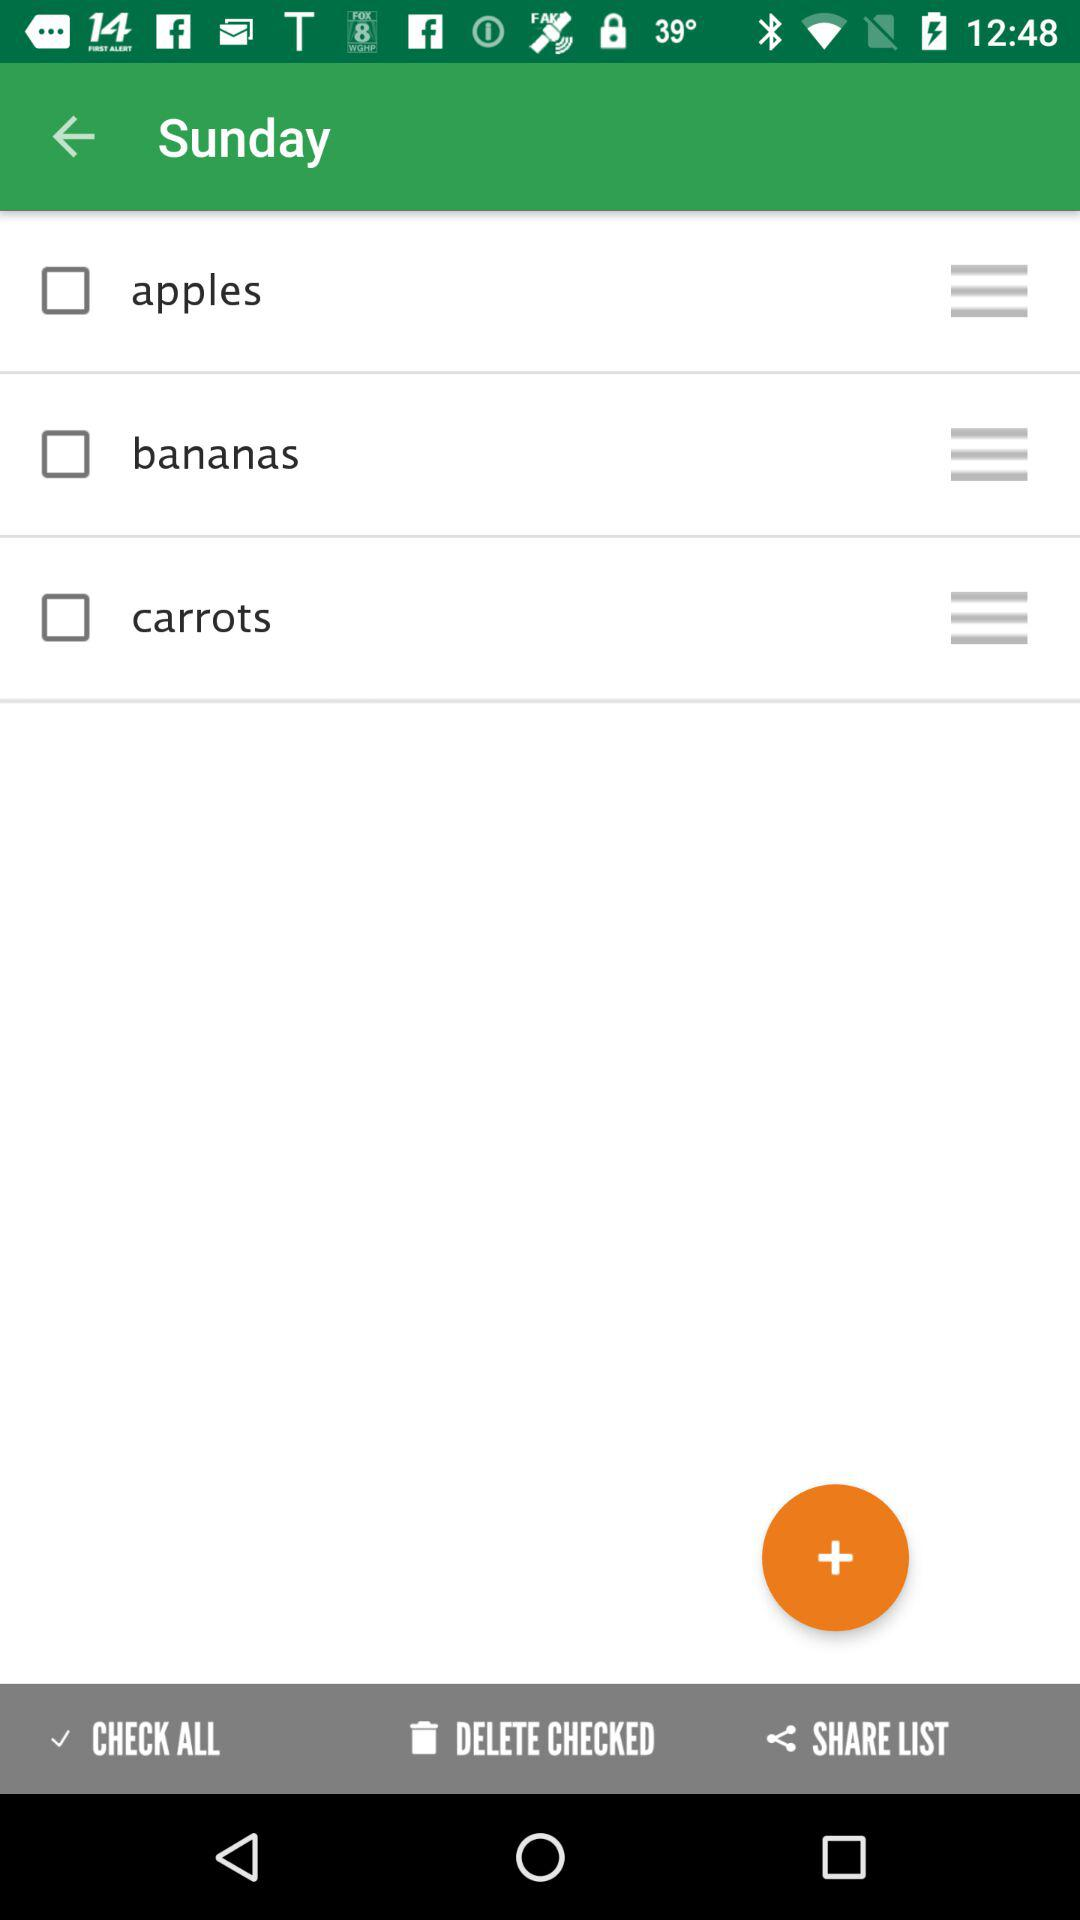How many items are checked?
Answer the question using a single word or phrase. 0 